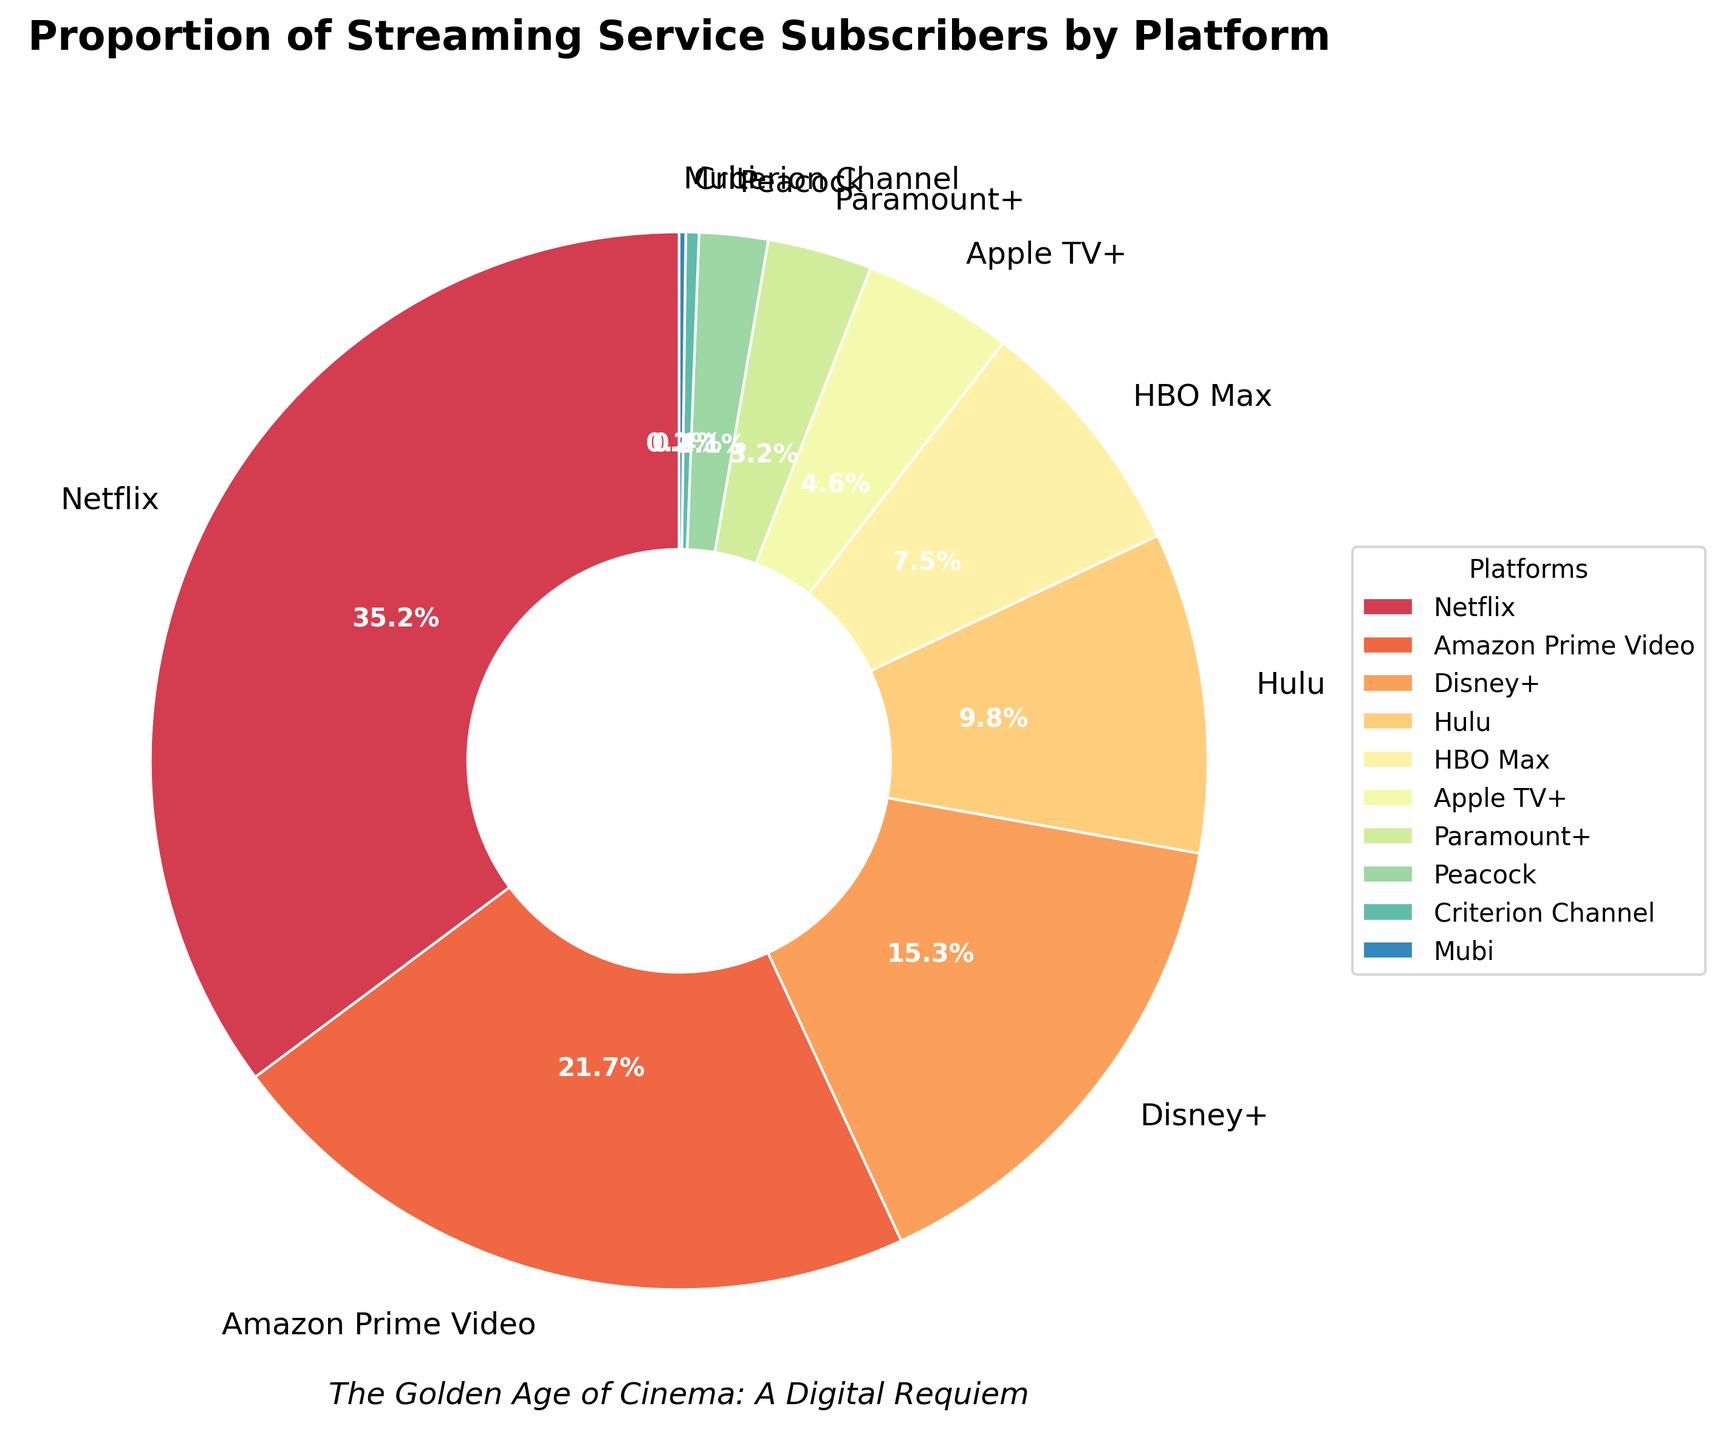Which streaming service has the highest proportion of subscribers? Identify the segment with the largest percentage value. Netflix has 35.2%, which is the highest.
Answer: Netflix How much higher is Netflix's subscriber proportion compared to Amazon Prime Video? Subtract the percentage of Amazon Prime Video (21.7%) from Netflix (35.2%). Calculation: 35.2 - 21.7 = 13.5
Answer: 13.5% Which platforms have less than 5% of the total subscribers? Look for segments with a percentage less than 5%. These platforms are Apple TV+ (4.6%), Paramount+ (3.2%), Peacock (2.1%), Criterion Channel (0.4%), and Mubi (0.2%).
Answer: Apple TV+, Paramount+, Peacock, Criterion Channel, Mubi What is the total percentage of subscribers for all platforms except Netflix and Amazon Prime Video? Add the percentages of all platforms except Netflix and Amazon Prime Video: 15.3 (Disney+) + 9.8 (Hulu) + 7.5 (HBO Max) + 4.6 (Apple TV+) + 3.2 (Paramount+) + 2.1 (Peacock) + 0.4 (Criterion Channel) + 0.2 (Mubi) = 43.1
Answer: 43.1% What is the visual attribute used to distinguish between different platforms in the pie chart? Identify the primary visual feature that differentiates the segments. The pie chart uses distinct colors for each platform.
Answer: Colors Which two services combined have close to the same proportion as Netflix alone? Find two platforms whose combined percentages are close to Netflix's 35.2%. Amazon Prime Video (21.7%) + Disney+ (15.3%) = 37.0%, which is close to Netflix's proportion.
Answer: Amazon Prime Video and Disney+ Compare the proportions of Disney+ and HBO Max. Which is larger and by how much? Subtract the percentage of HBO Max (7.5%) from Disney+ (15.3%). Calculation: 15.3 - 7.5 = 7.8
Answer: Disney+, by 7.8% What is the combined percentage of Criterion Channel and Mubi? Add the percentages of Criterion Channel (0.4%) and Mubi (0.2%). Calculation: 0.4 + 0.2 = 0.6
Answer: 0.6% How many platforms have a higher proportion of subscribers than Hulu? Count the segments with proportions greater than 9.8%. These platforms are Netflix, Amazon Prime Video, and Disney+ (3 platforms total).
Answer: 3 platforms Which streaming service appears to have the smallest proportion of subscribers and what is the percentage? Identify the segment with the smallest percentage. Mubi has the smallest with 0.2%.
Answer: Mubi, 0.2% 